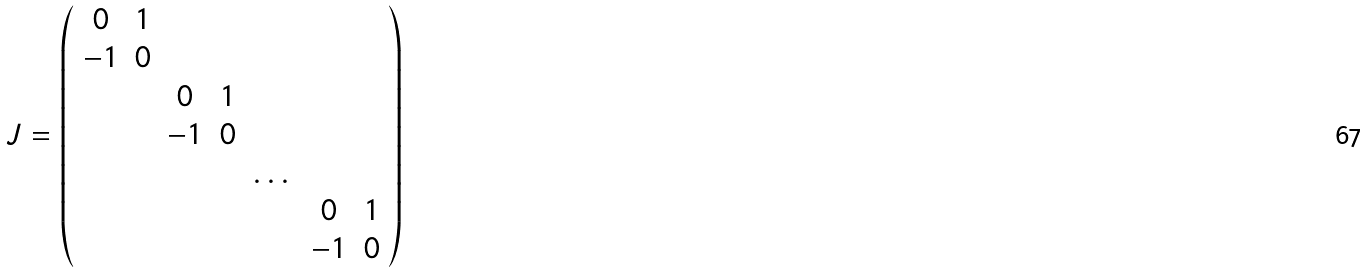Convert formula to latex. <formula><loc_0><loc_0><loc_500><loc_500>J = \left ( \begin{array} { c c c c c c c } 0 & 1 & & & & & \\ - 1 & 0 & & & & & \\ & & 0 & 1 & & & \\ & & - 1 & 0 & & & \\ & & & & \dots & & \\ & & & & & 0 & 1 \\ & & & & & - 1 & 0 \end{array} \right )</formula> 